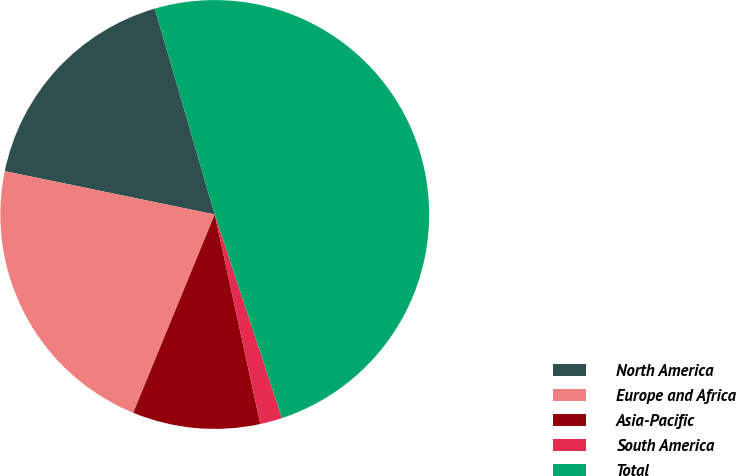Convert chart to OTSL. <chart><loc_0><loc_0><loc_500><loc_500><pie_chart><fcel>North America<fcel>Europe and Africa<fcel>Asia-Pacific<fcel>South America<fcel>Total<nl><fcel>17.25%<fcel>22.03%<fcel>9.62%<fcel>1.66%<fcel>49.44%<nl></chart> 